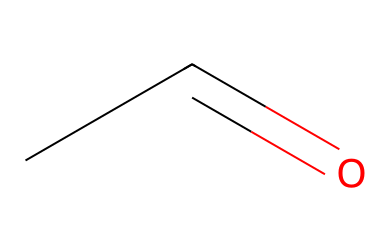What is the name of this chemical? The SMILES representation CC=O corresponds to acetic aldehyde, also known as acetaldehyde, which is a well-known aldehyde compound.
Answer: acetaldehyde How many carbon atoms are in this molecule? Analyzing the SMILES structure CC=O shows there are two carbon atoms (both represented by the 'C' in CC).
Answer: 2 What is the functional group present in this chemical? The structure CC=O indicates that the molecule has a carbonyl group (C=O) at the end of the carbon chain, typical for aldehydes.
Answer: carbonyl What is the total number of hydrogen atoms in acetaldehyde? In the structure CC=O, the two carbon atoms can bond with five hydrogen atoms as follows: one carbon bonded to three hydrogens (C-H3) and the other carbon bonded to one hydrogen and the carbonyl (C-H).
Answer: 4 What type of chemical is acetaldehyde? Given that acetaldehyde contains the carbonyl group at the terminal position and follows the general formula for aldehydes (RCHO), it classifies it specifically as an aldehyde.
Answer: aldehyde What is the degree of unsaturation in acetaldehyde? The degree of unsaturation accounts for rings and double bonds; with one double bond from the carbonyl (C=O) and no rings, acetaldehyde has a degree of unsaturation equal to one.
Answer: 1 Is acetaldehyde a saturated or unsaturated compound? Due to the presence of a double bond in its structure (the carbonyl group), acetaldehyde is defined as an unsaturated compound.
Answer: unsaturated 